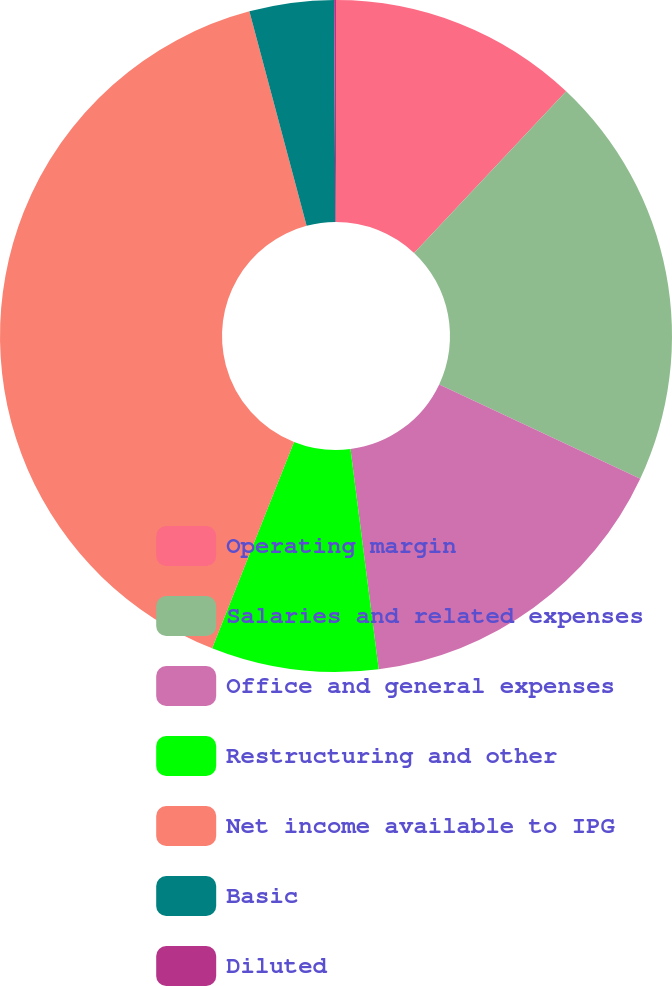Convert chart to OTSL. <chart><loc_0><loc_0><loc_500><loc_500><pie_chart><fcel>Operating margin<fcel>Salaries and related expenses<fcel>Office and general expenses<fcel>Restructuring and other<fcel>Net income available to IPG<fcel>Basic<fcel>Diluted<nl><fcel>12.01%<fcel>19.97%<fcel>15.99%<fcel>8.04%<fcel>39.84%<fcel>4.06%<fcel>0.09%<nl></chart> 